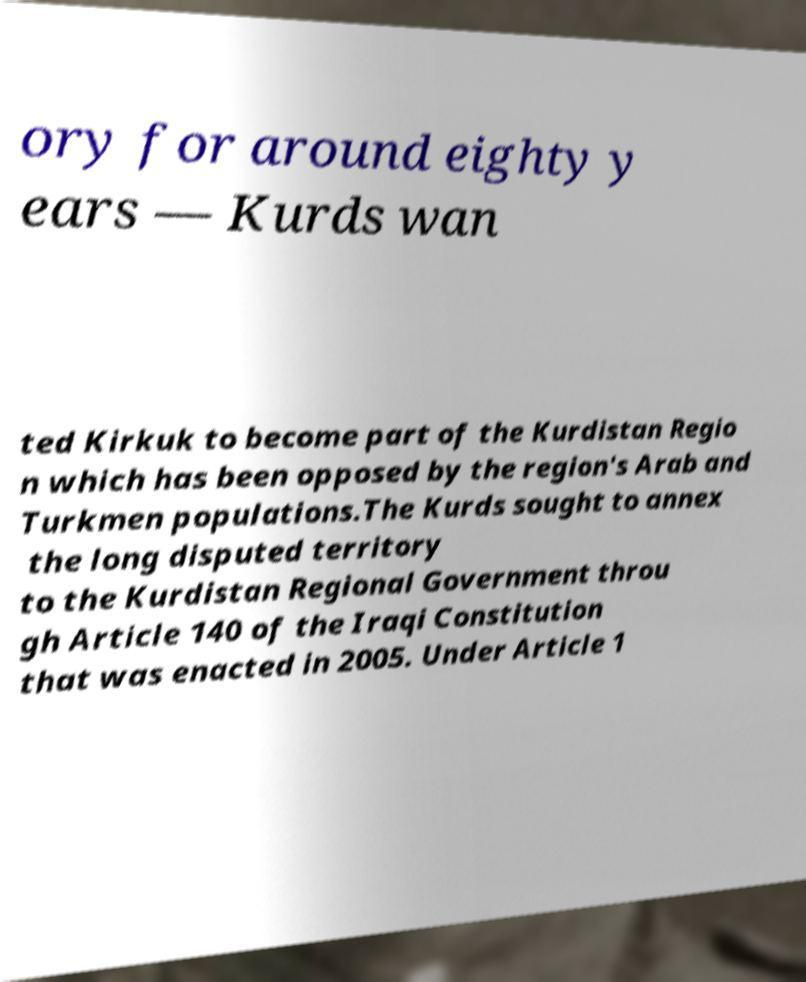There's text embedded in this image that I need extracted. Can you transcribe it verbatim? ory for around eighty y ears — Kurds wan ted Kirkuk to become part of the Kurdistan Regio n which has been opposed by the region's Arab and Turkmen populations.The Kurds sought to annex the long disputed territory to the Kurdistan Regional Government throu gh Article 140 of the Iraqi Constitution that was enacted in 2005. Under Article 1 